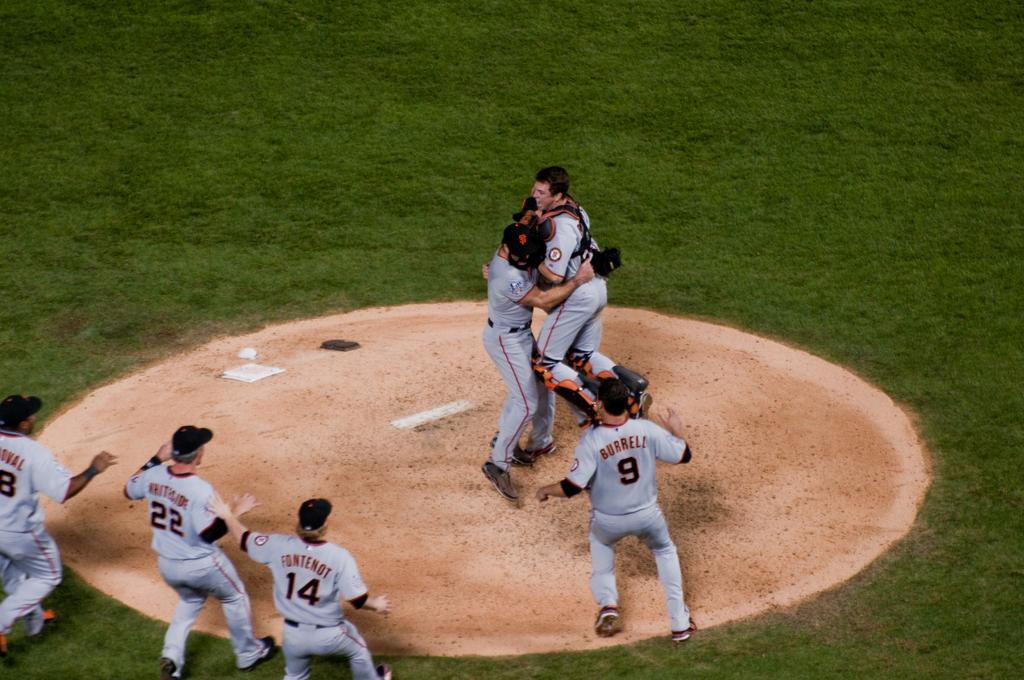<image>
Provide a brief description of the given image. Baseball players Burrell, Whiteside, Fontenot and others race to the pitcher's mound to celenbrate. 